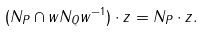Convert formula to latex. <formula><loc_0><loc_0><loc_500><loc_500>( N _ { P } \cap w N _ { Q } w ^ { - 1 } ) \cdot z = N _ { P } \cdot z .</formula> 